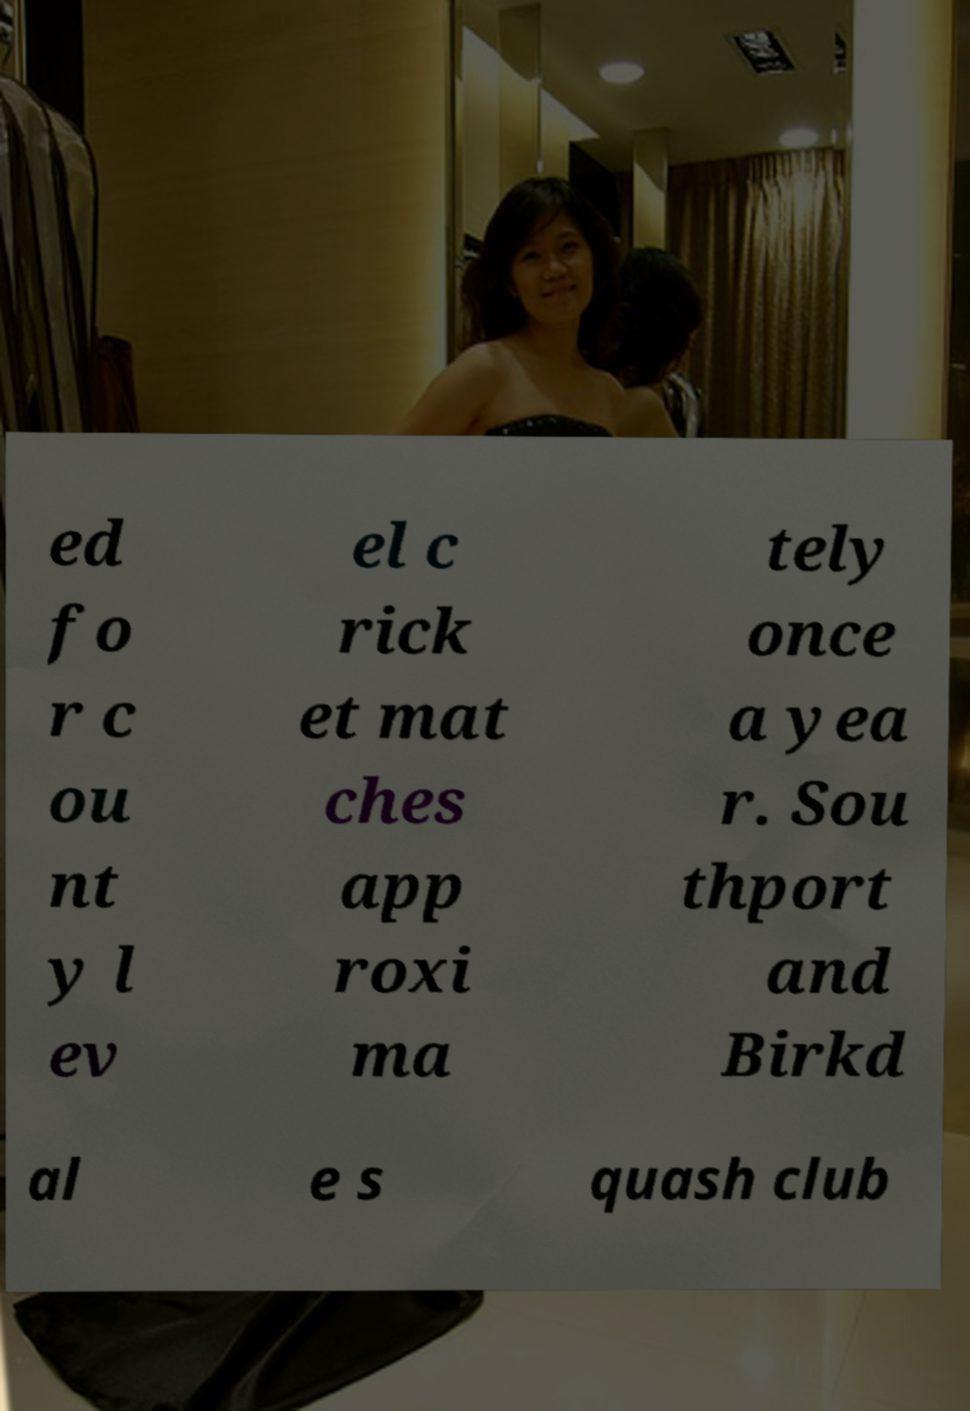Please read and relay the text visible in this image. What does it say? ed fo r c ou nt y l ev el c rick et mat ches app roxi ma tely once a yea r. Sou thport and Birkd al e s quash club 